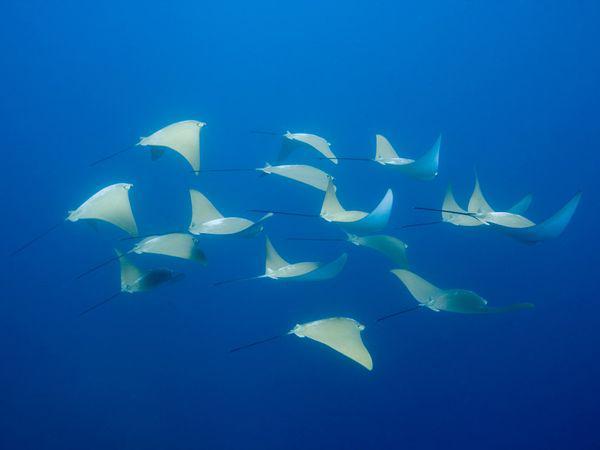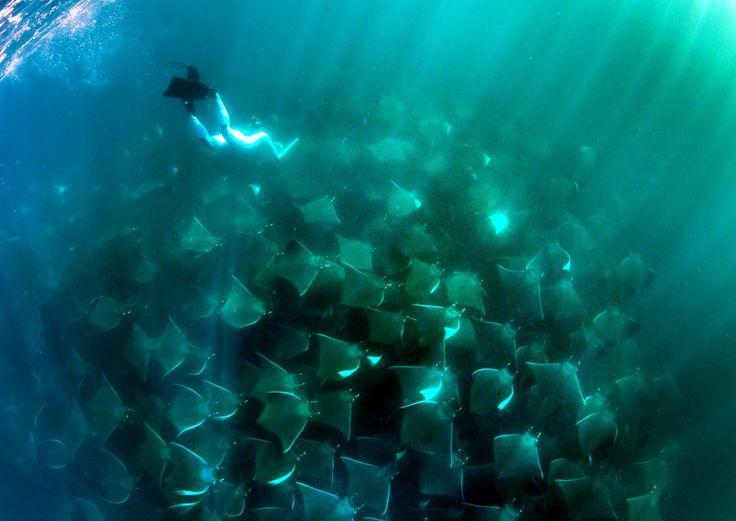The first image is the image on the left, the second image is the image on the right. Examine the images to the left and right. Is the description "At least one image in the pair shows a single stingray." accurate? Answer yes or no. No. The first image is the image on the left, the second image is the image on the right. Analyze the images presented: Is the assertion "the left image shows a sea full of stingray from the top view" valid? Answer yes or no. No. 